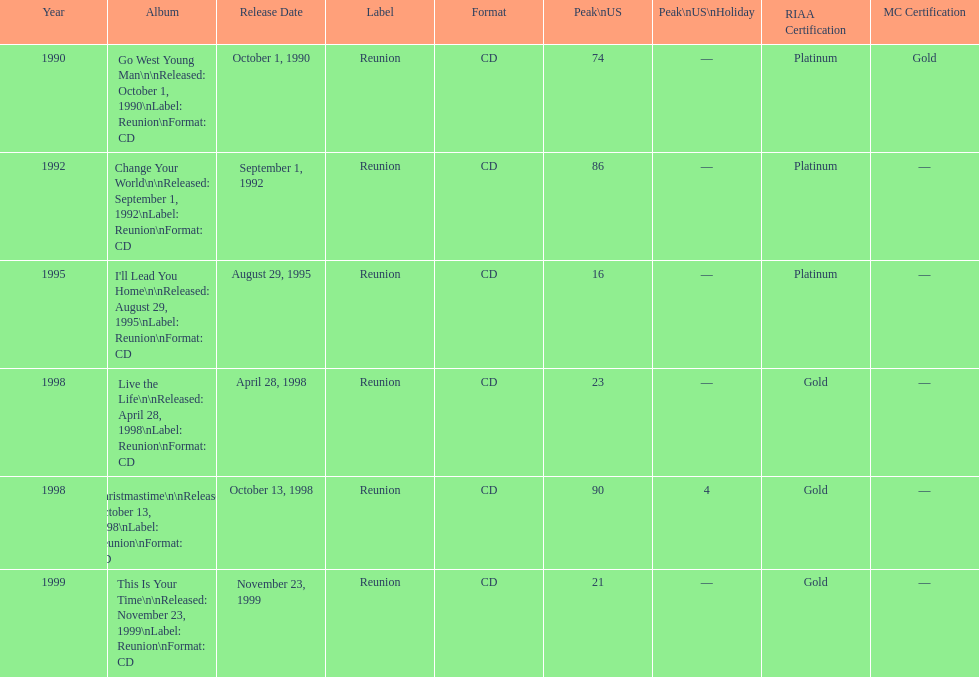How many songs are listed from 1998? 2. 